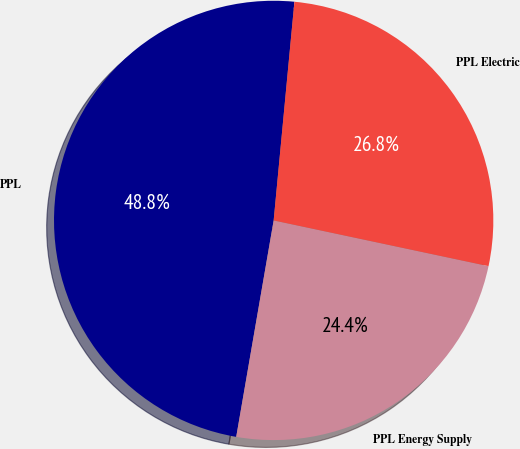Convert chart to OTSL. <chart><loc_0><loc_0><loc_500><loc_500><pie_chart><fcel>PPL<fcel>PPL Energy Supply<fcel>PPL Electric<nl><fcel>48.78%<fcel>24.39%<fcel>26.83%<nl></chart> 